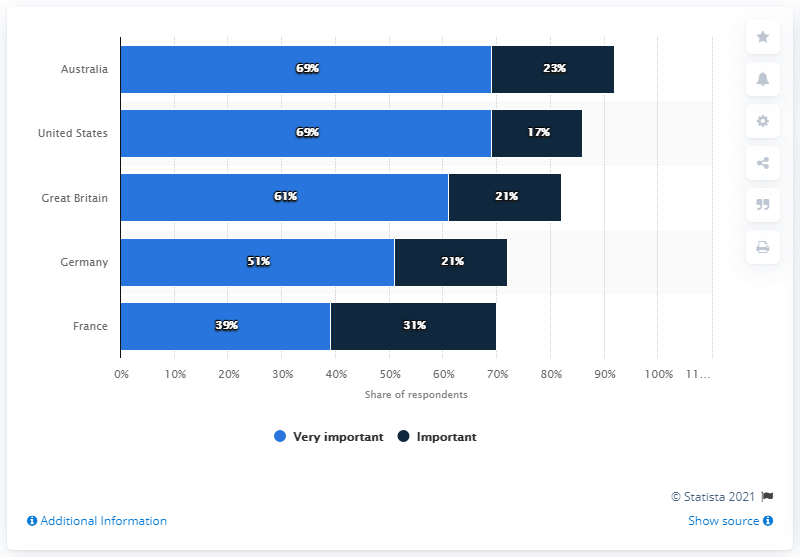Outline some significant characteristics in this image. According to the survey, Australia has the highest percentage of respondents. What is the difference between Germany and France in their very important reviews? 